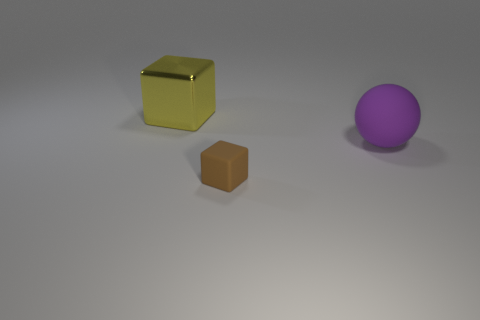Add 2 yellow cubes. How many objects exist? 5 Subtract 1 blocks. How many blocks are left? 1 Subtract all blocks. How many objects are left? 1 Subtract all gray blocks. Subtract all brown balls. How many blocks are left? 2 Subtract all green spheres. How many cyan cubes are left? 0 Subtract all big yellow shiny things. Subtract all large purple objects. How many objects are left? 1 Add 1 brown objects. How many brown objects are left? 2 Add 2 metallic things. How many metallic things exist? 3 Subtract 0 yellow cylinders. How many objects are left? 3 